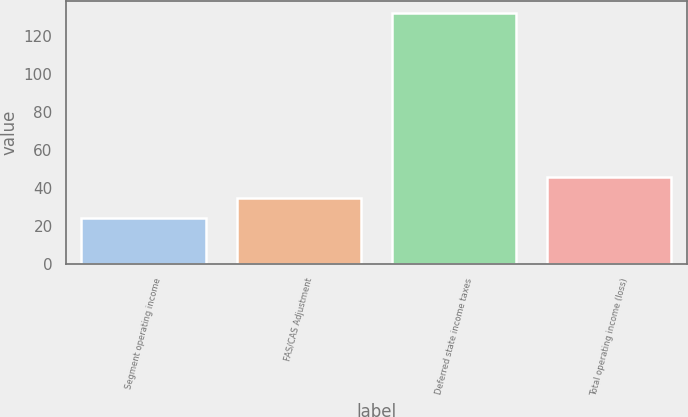Convert chart to OTSL. <chart><loc_0><loc_0><loc_500><loc_500><bar_chart><fcel>Segment operating income<fcel>FAS/CAS Adjustment<fcel>Deferred state income taxes<fcel>Total operating income (loss)<nl><fcel>24<fcel>34.8<fcel>132<fcel>45.6<nl></chart> 